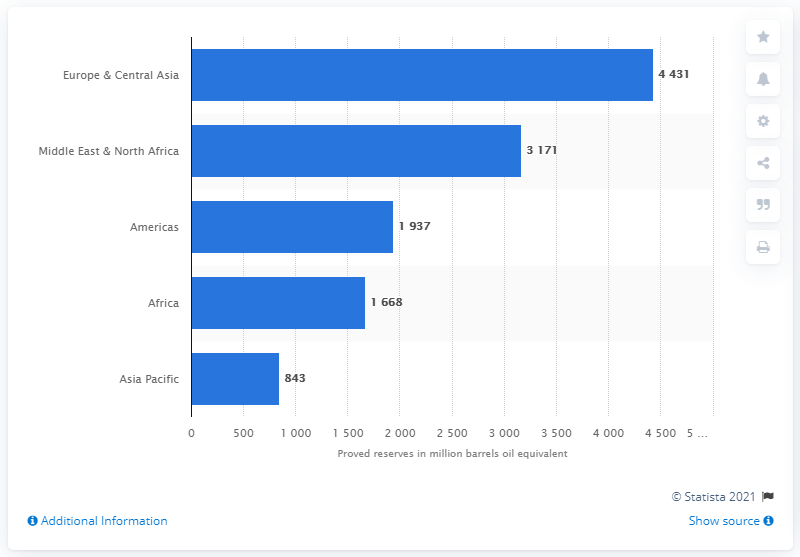Draw attention to some important aspects in this diagram. As of 2020, Total SE had approximately 4,431 barrels of oil equivalent reserves in Europe and Central Asia. 